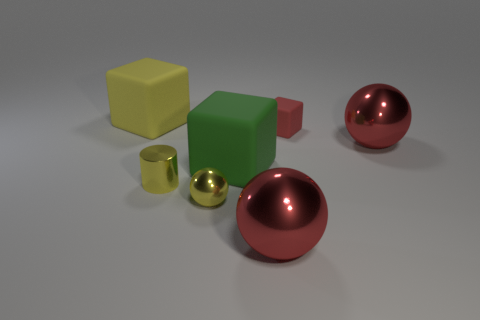Add 2 gray blocks. How many objects exist? 9 Subtract all cubes. How many objects are left? 4 Subtract all small red spheres. Subtract all big yellow things. How many objects are left? 6 Add 5 small yellow cylinders. How many small yellow cylinders are left? 6 Add 2 green objects. How many green objects exist? 3 Subtract 1 yellow spheres. How many objects are left? 6 